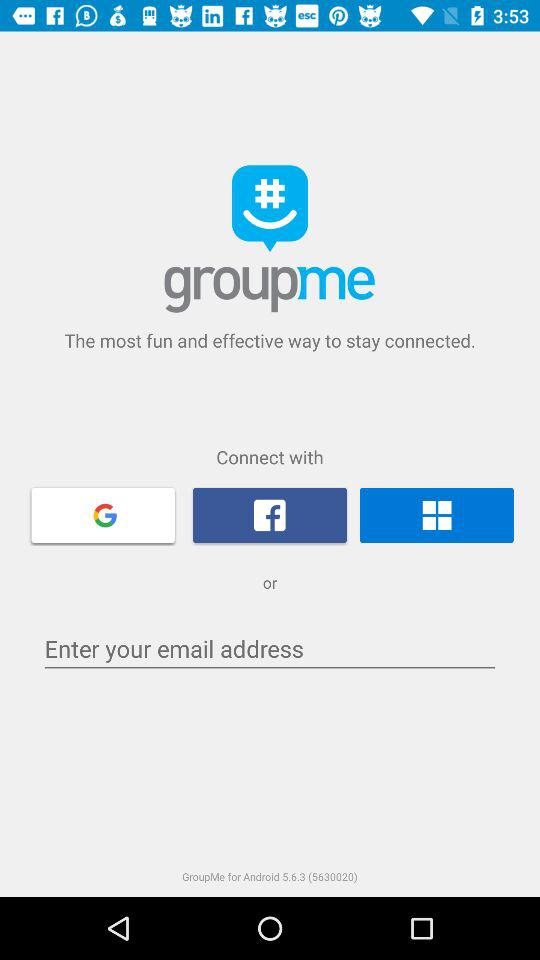What Android version is supported for the application? The supported Android version for the application is 5.6.3 (5630020). 